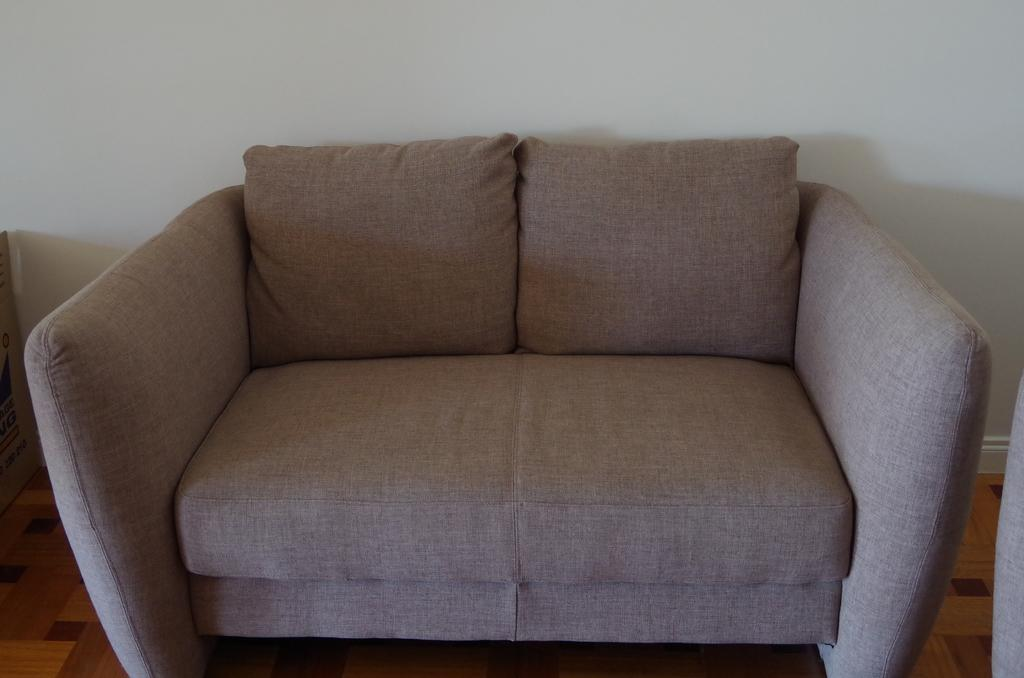What type of furniture is present in the image? There is a couch in the image. What color is the couch? The couch is light purple in color. What can be seen in the background of the image? There is a wall in the background of the image. What type of potato is sitting on the couch in the image? There is no potato present in the image; it only features a light purple couch and a wall in the background. 